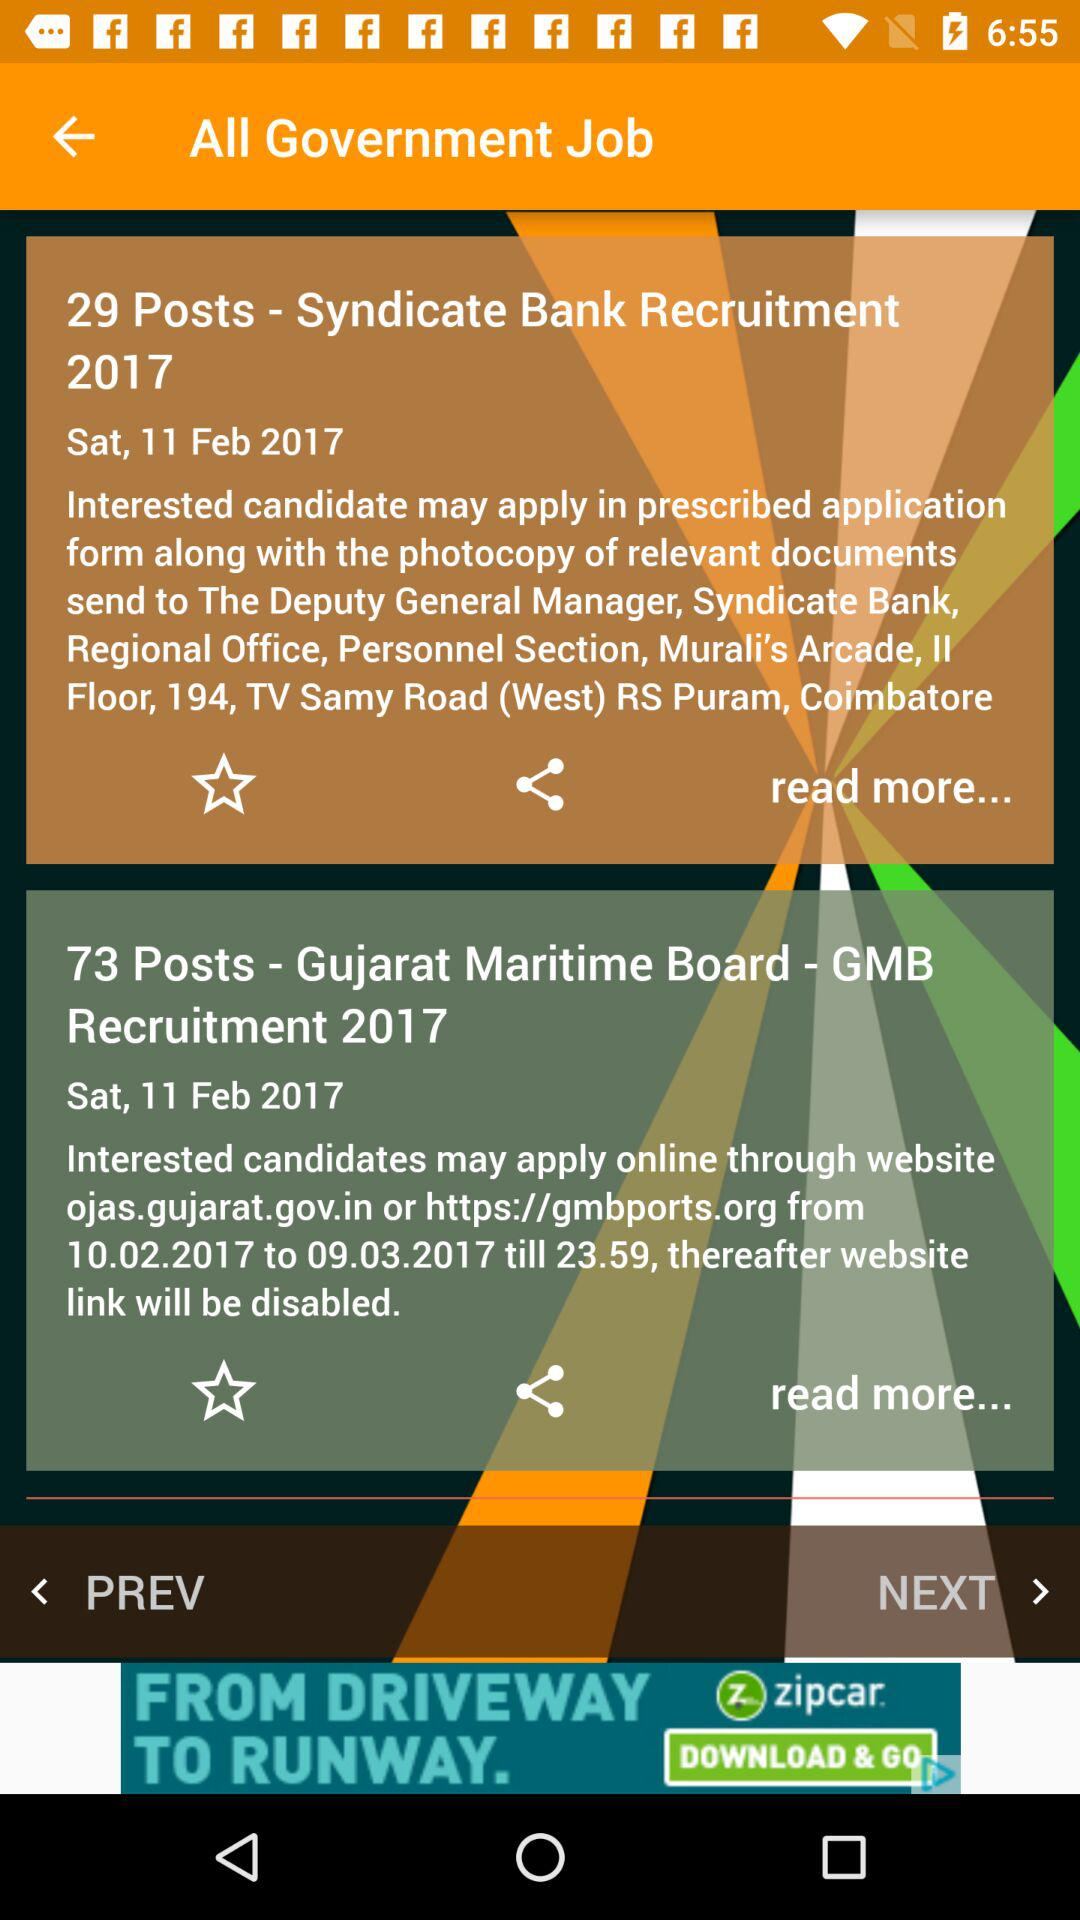How many more posts are available in the Gujarat Maritime Board - GMB Recruitment 2017 than in the Syndicate Bank Recruitment 2017?
Answer the question using a single word or phrase. 44 